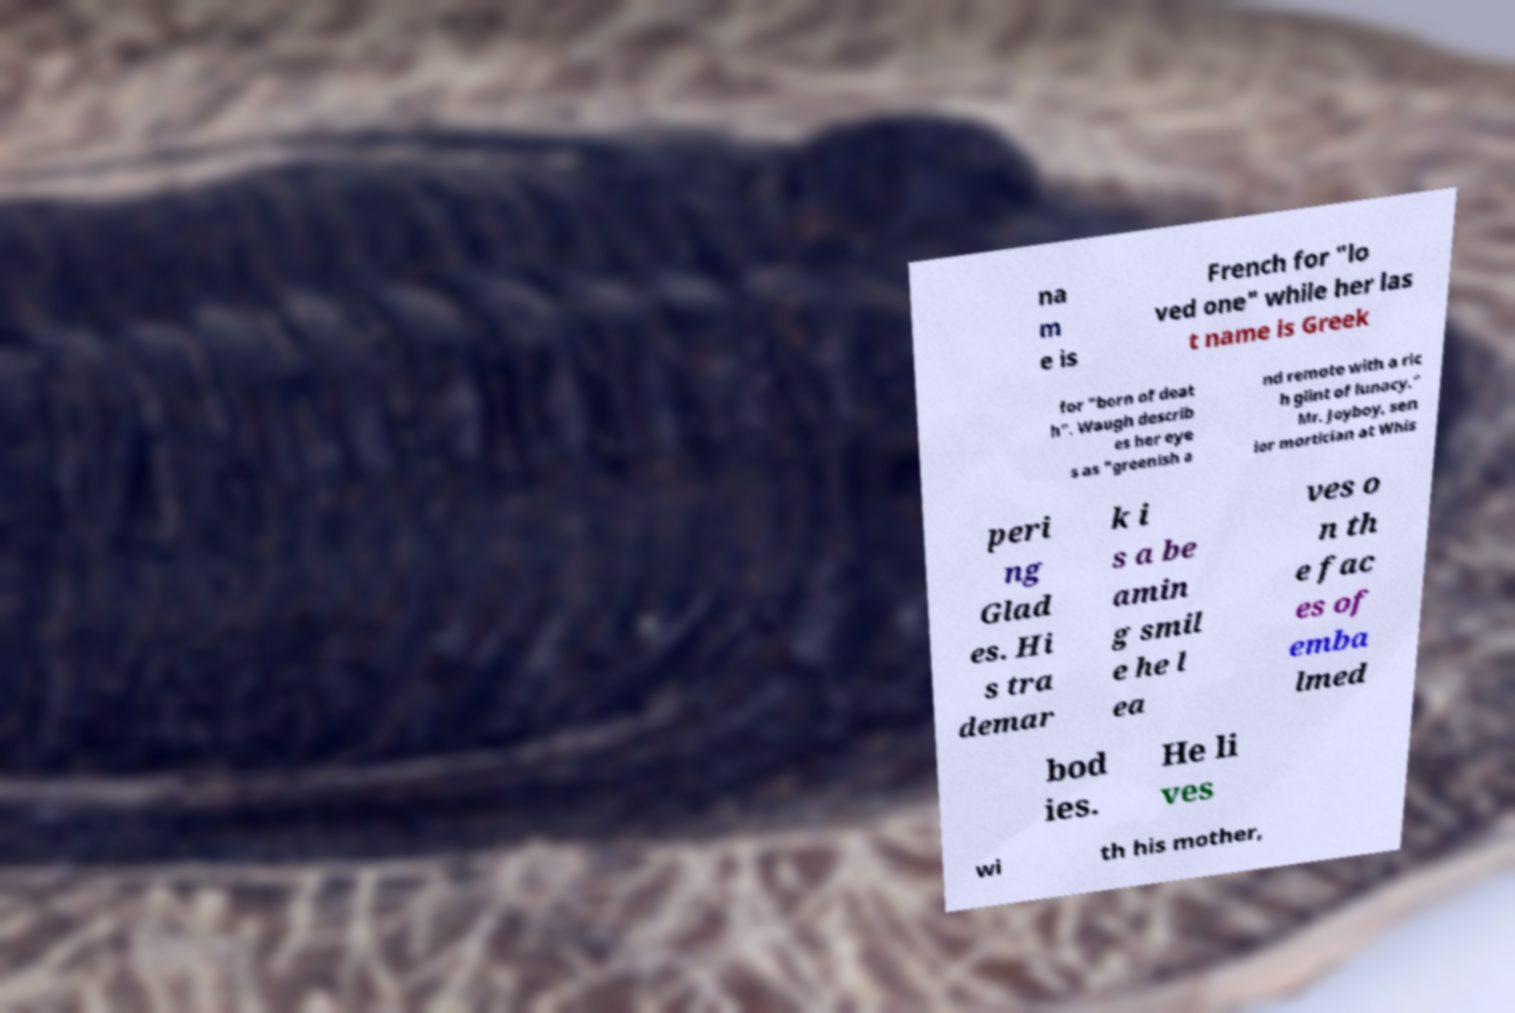Could you assist in decoding the text presented in this image and type it out clearly? na m e is French for "lo ved one" while her las t name is Greek for "born of deat h". Waugh describ es her eye s as "greenish a nd remote with a ric h glint of lunacy." Mr. Joyboy, sen ior mortician at Whis peri ng Glad es. Hi s tra demar k i s a be amin g smil e he l ea ves o n th e fac es of emba lmed bod ies. He li ves wi th his mother, 